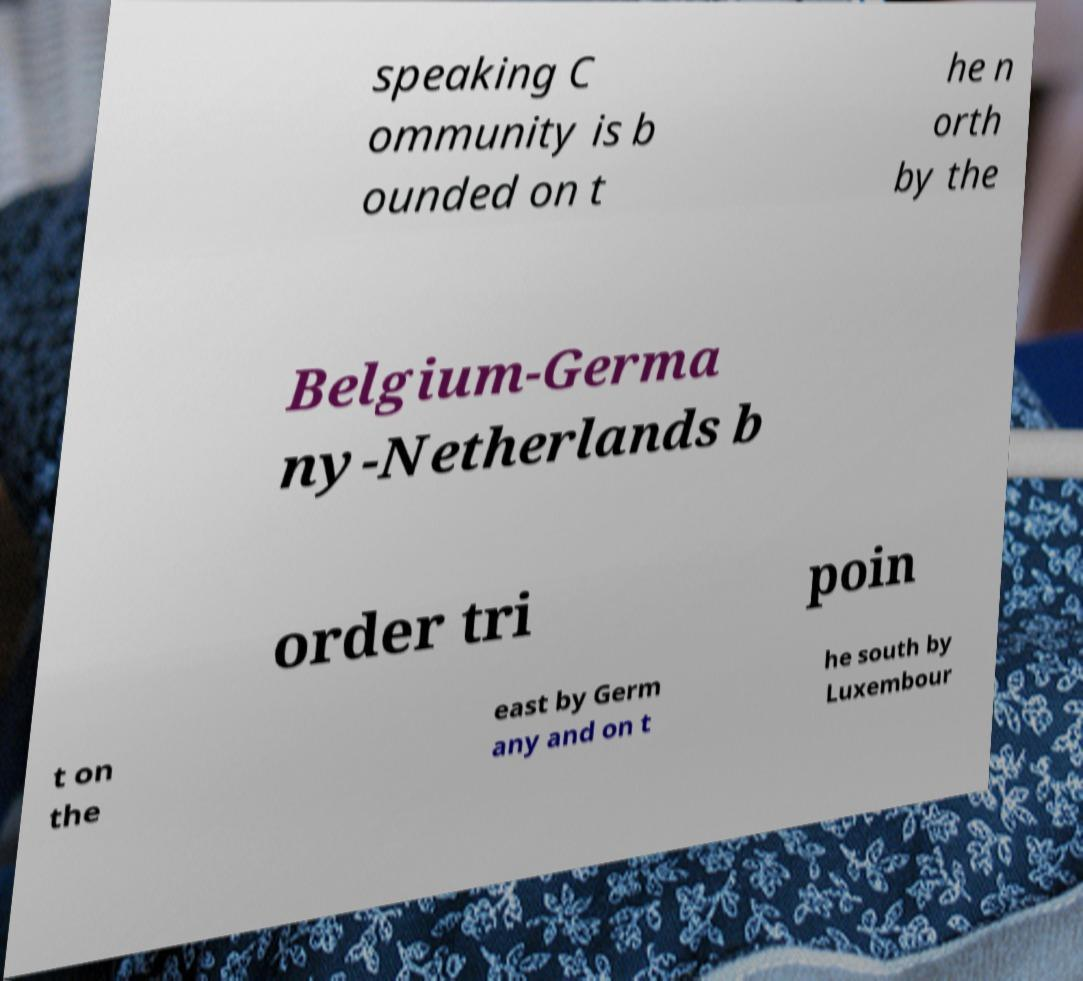Could you assist in decoding the text presented in this image and type it out clearly? speaking C ommunity is b ounded on t he n orth by the Belgium-Germa ny-Netherlands b order tri poin t on the east by Germ any and on t he south by Luxembour 